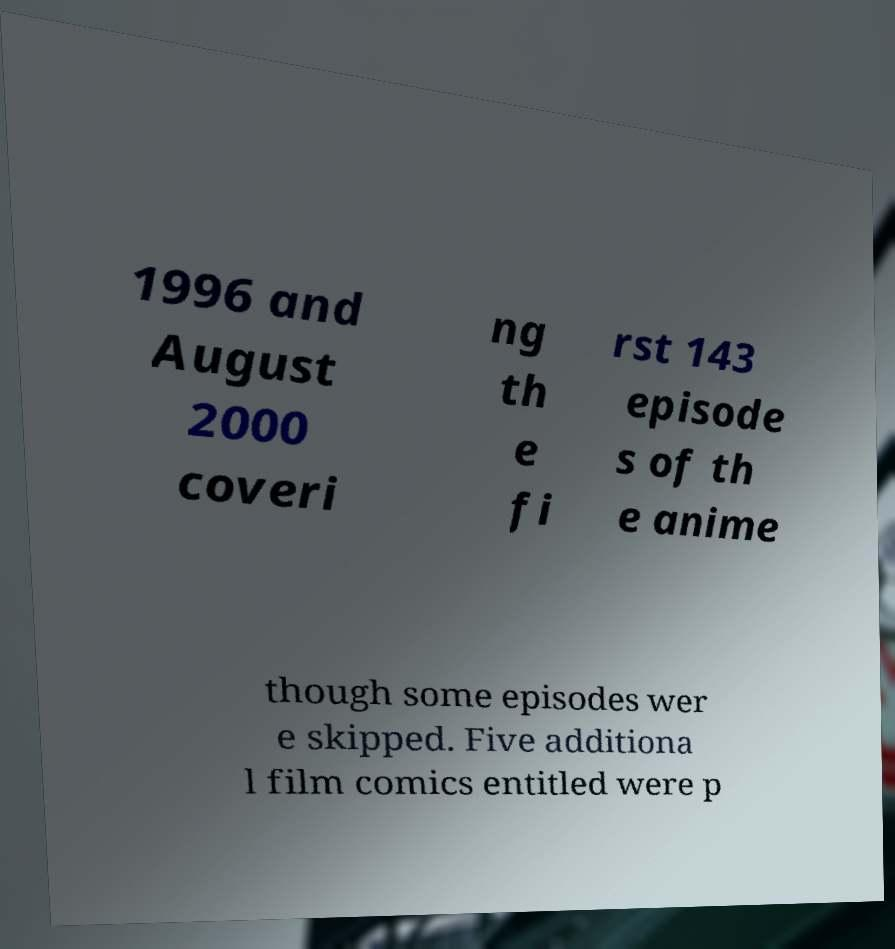Can you accurately transcribe the text from the provided image for me? 1996 and August 2000 coveri ng th e fi rst 143 episode s of th e anime though some episodes wer e skipped. Five additiona l film comics entitled were p 